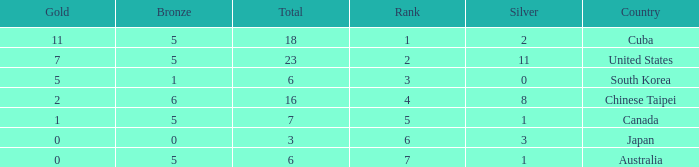What was the sum of the ranks for Japan who had less than 5 bronze medals and more than 3 silvers? None. 